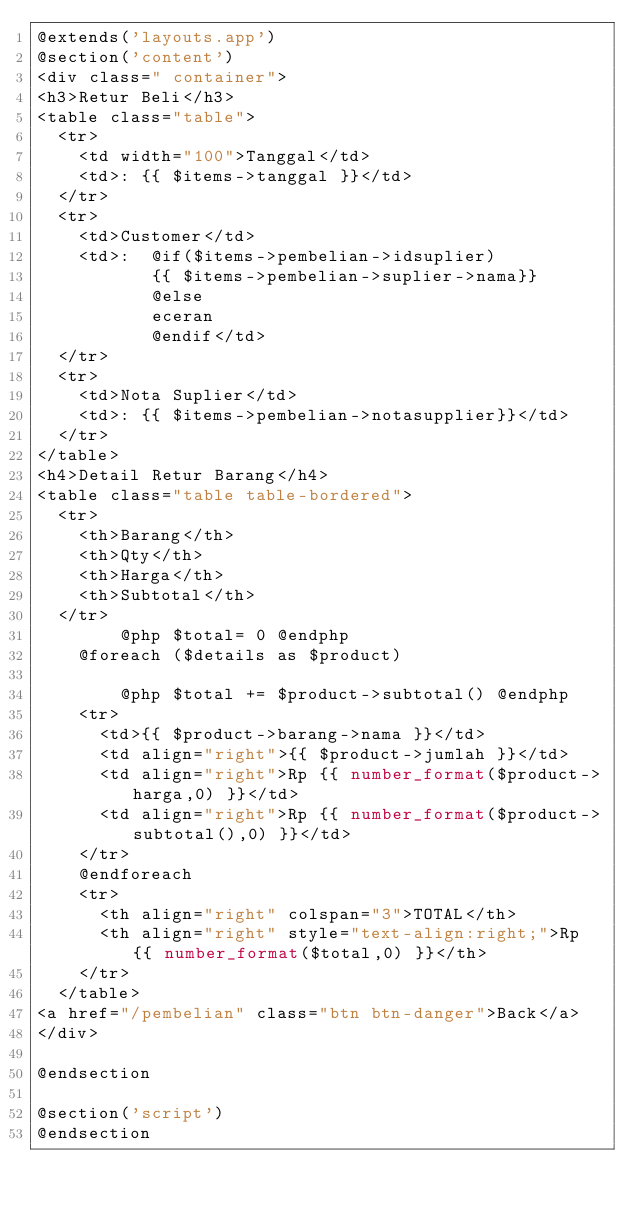<code> <loc_0><loc_0><loc_500><loc_500><_PHP_>@extends('layouts.app')
@section('content')
<div class=" container">
<h3>Retur Beli</h3>
<table class="table">
  <tr>
    <td width="100">Tanggal</td>
    <td>: {{ $items->tanggal }}</td>
  </tr>
  <tr>
    <td>Customer</td>
    <td>:  @if($items->pembelian->idsuplier) 
           {{ $items->pembelian->suplier->nama}}
           @else
           eceran
           @endif</td>
  </tr>
  <tr>
    <td>Nota Suplier</td>
    <td>: {{ $items->pembelian->notasupplier}}</td>
  </tr>
</table>
<h4>Detail Retur Barang</h4>
<table class="table table-bordered">
  <tr>
    <th>Barang</th>
    <th>Qty</th>
    <th>Harga</th>
    <th>Subtotal</th>
  </tr>
        @php $total= 0 @endphp
    @foreach ($details as $product)

        @php $total += $product->subtotal() @endphp
    <tr>
      <td>{{ $product->barang->nama }}</td>
      <td align="right">{{ $product->jumlah }}</td>
      <td align="right">Rp {{ number_format($product->harga,0) }}</td>
      <td align="right">Rp {{ number_format($product->subtotal(),0) }}</td>
    </tr>
    @endforeach
    <tr>
      <th align="right" colspan="3">TOTAL</th>
      <th align="right" style="text-align:right;">Rp {{ number_format($total,0) }}</th>
    </tr>
  </table>
<a href="/pembelian" class="btn btn-danger">Back</a>
</div>

@endsection

@section('script')
@endsection</code> 